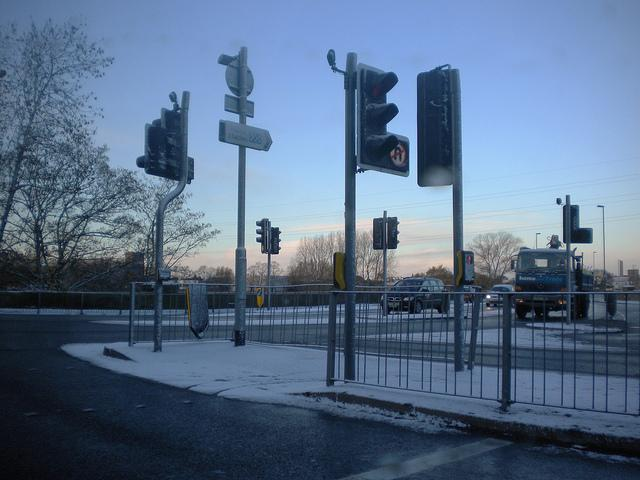What are drivers told is forbidden?

Choices:
A) go straight
B) turn left
C) u-turns
D) yield u-turns 